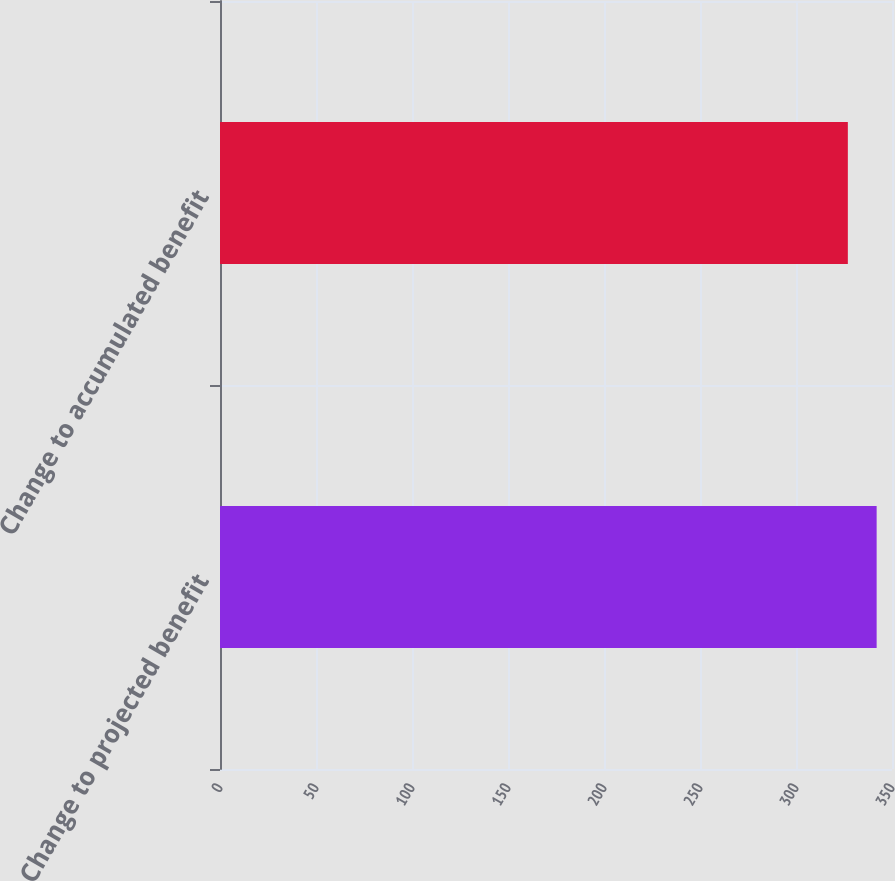<chart> <loc_0><loc_0><loc_500><loc_500><bar_chart><fcel>Change to projected benefit<fcel>Change to accumulated benefit<nl><fcel>342<fcel>327<nl></chart> 